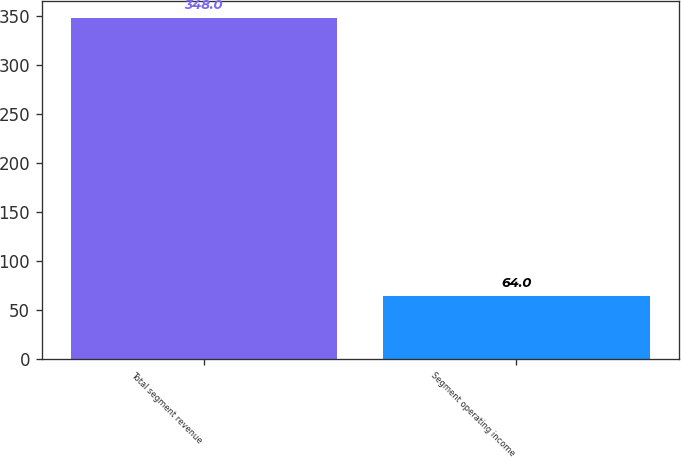<chart> <loc_0><loc_0><loc_500><loc_500><bar_chart><fcel>Total segment revenue<fcel>Segment operating income<nl><fcel>348<fcel>64<nl></chart> 